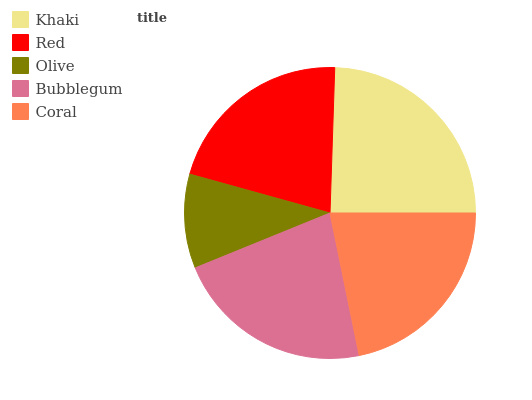Is Olive the minimum?
Answer yes or no. Yes. Is Khaki the maximum?
Answer yes or no. Yes. Is Red the minimum?
Answer yes or no. No. Is Red the maximum?
Answer yes or no. No. Is Khaki greater than Red?
Answer yes or no. Yes. Is Red less than Khaki?
Answer yes or no. Yes. Is Red greater than Khaki?
Answer yes or no. No. Is Khaki less than Red?
Answer yes or no. No. Is Coral the high median?
Answer yes or no. Yes. Is Coral the low median?
Answer yes or no. Yes. Is Olive the high median?
Answer yes or no. No. Is Red the low median?
Answer yes or no. No. 